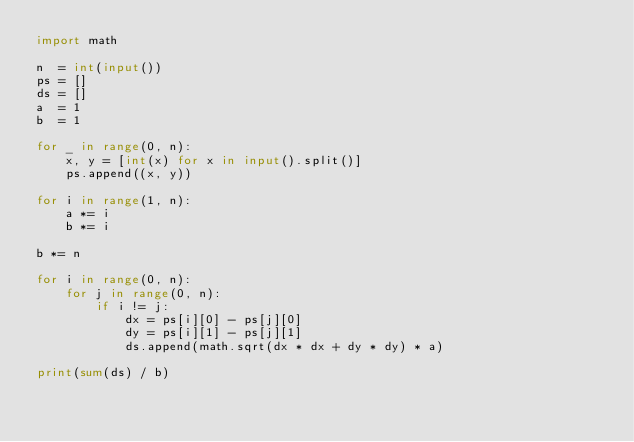<code> <loc_0><loc_0><loc_500><loc_500><_Python_>import math

n  = int(input())
ps = []
ds = []
a  = 1
b  = 1

for _ in range(0, n):
	x, y = [int(x) for x in input().split()]
	ps.append((x, y))

for i in range(1, n):
	a *= i
	b *= i

b *= n

for i in range(0, n):
	for j in range(0, n):
		if i != j:
			dx = ps[i][0] - ps[j][0]
			dy = ps[i][1] - ps[j][1]
			ds.append(math.sqrt(dx * dx + dy * dy) * a)

print(sum(ds) / b)
</code> 